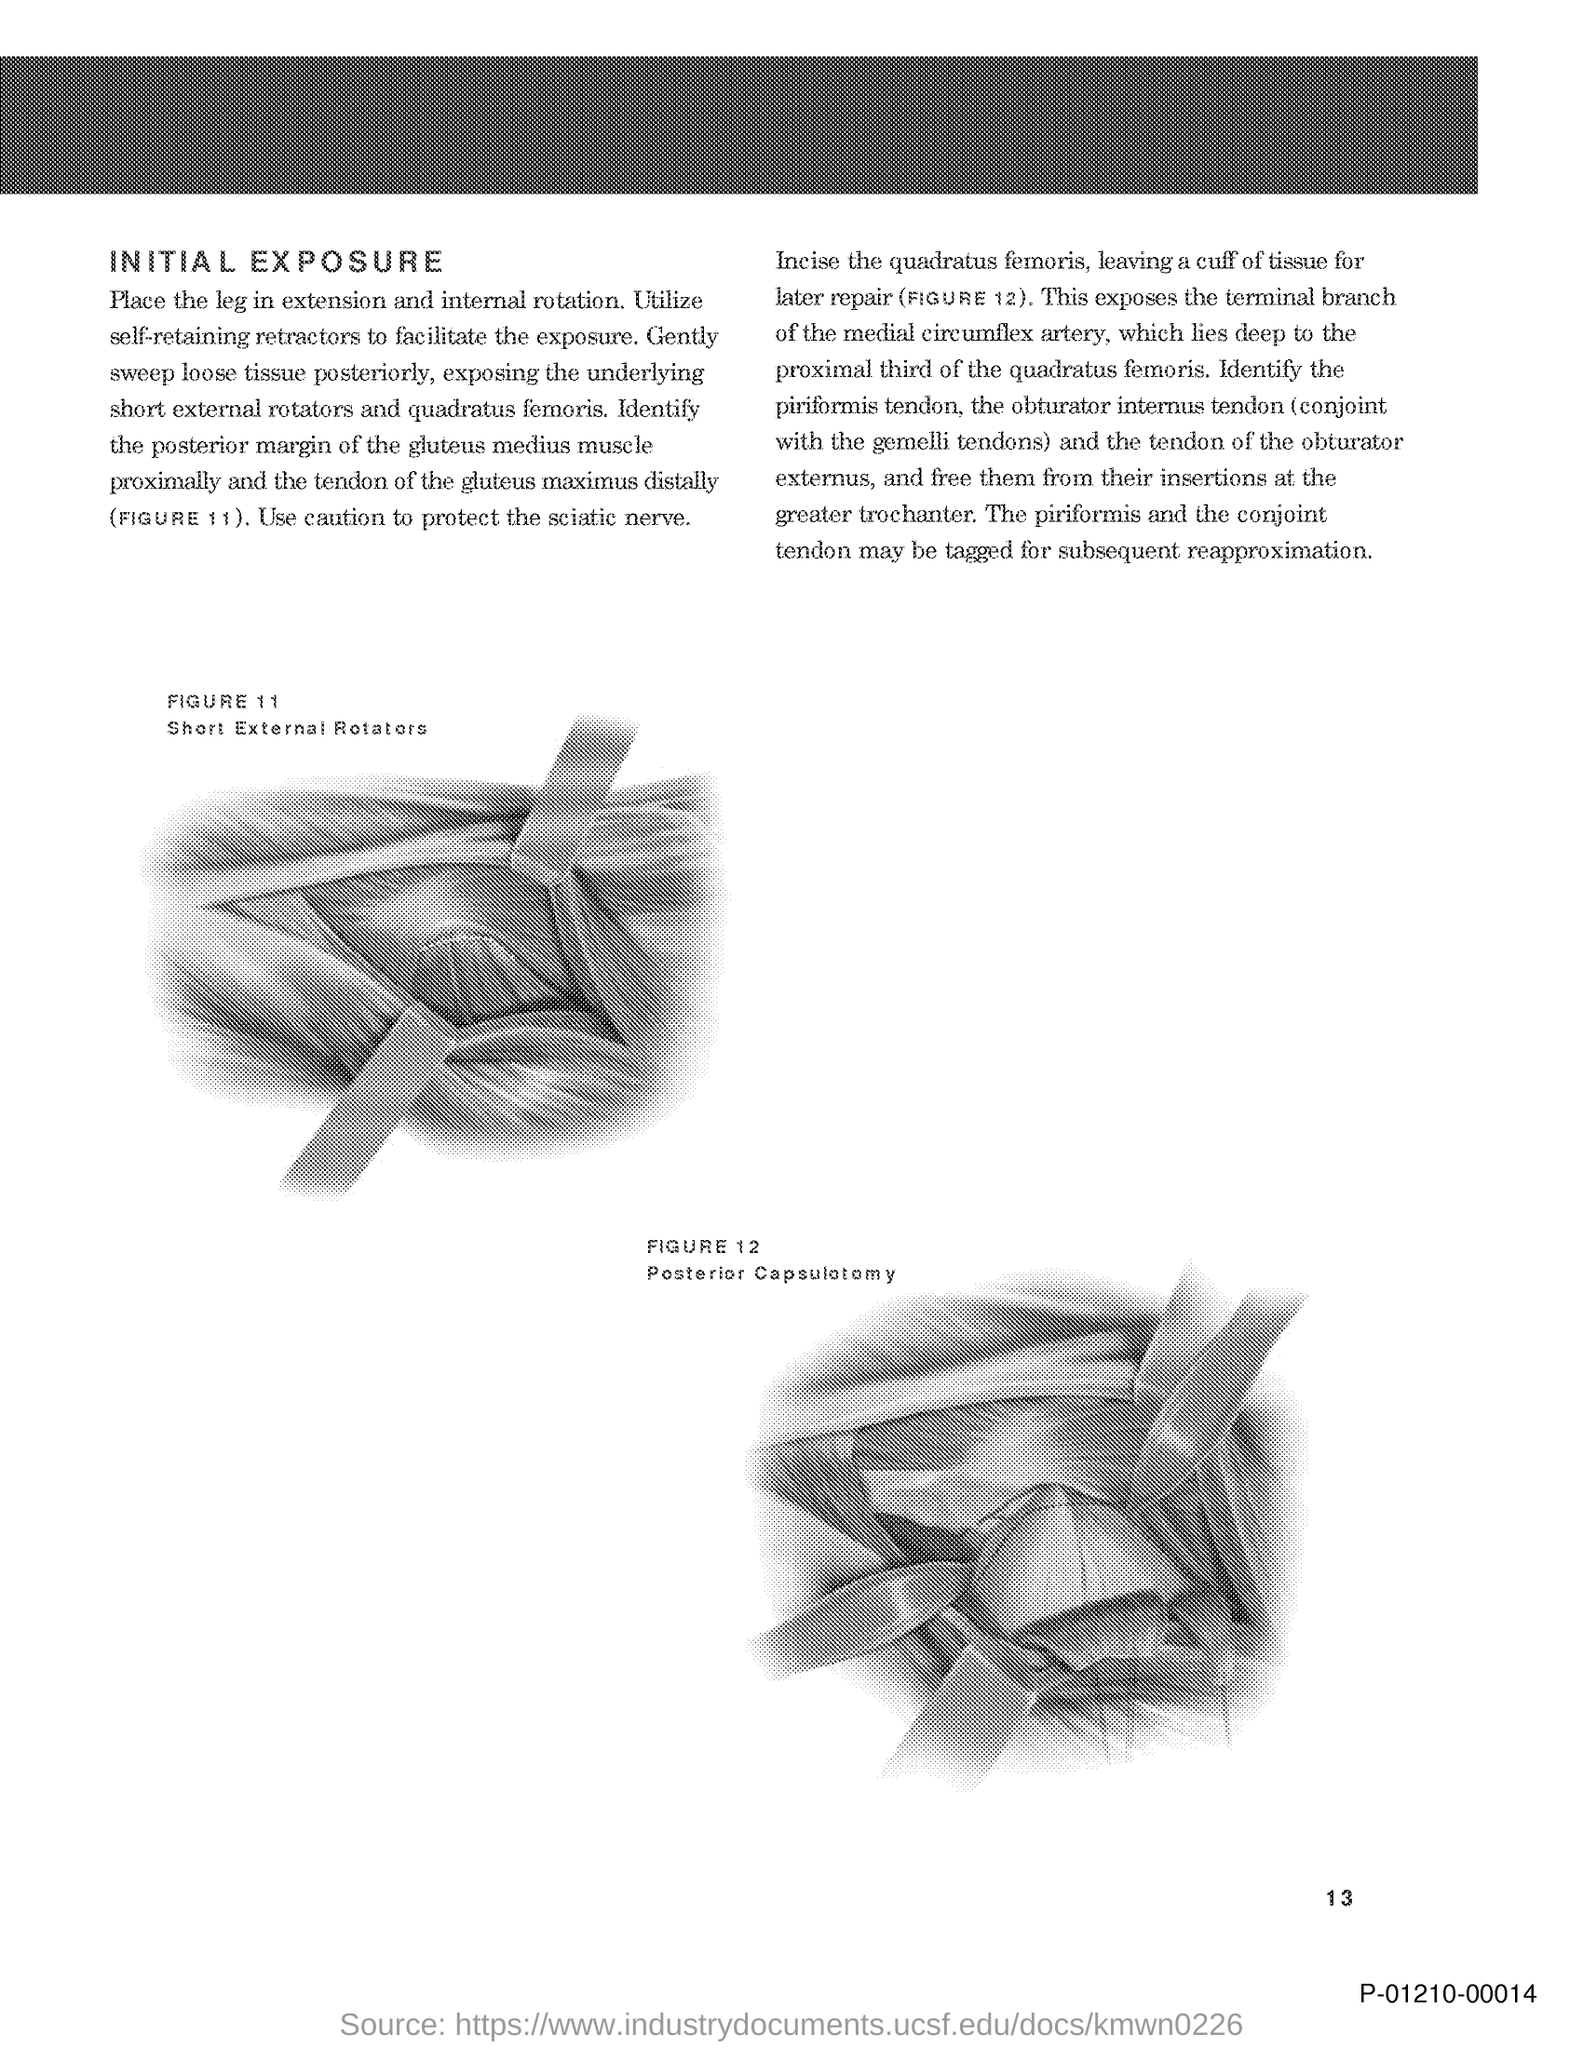What is the first title in the document?
Your response must be concise. Initial Exposure. What is the Page Number?
Offer a terse response. 13. 